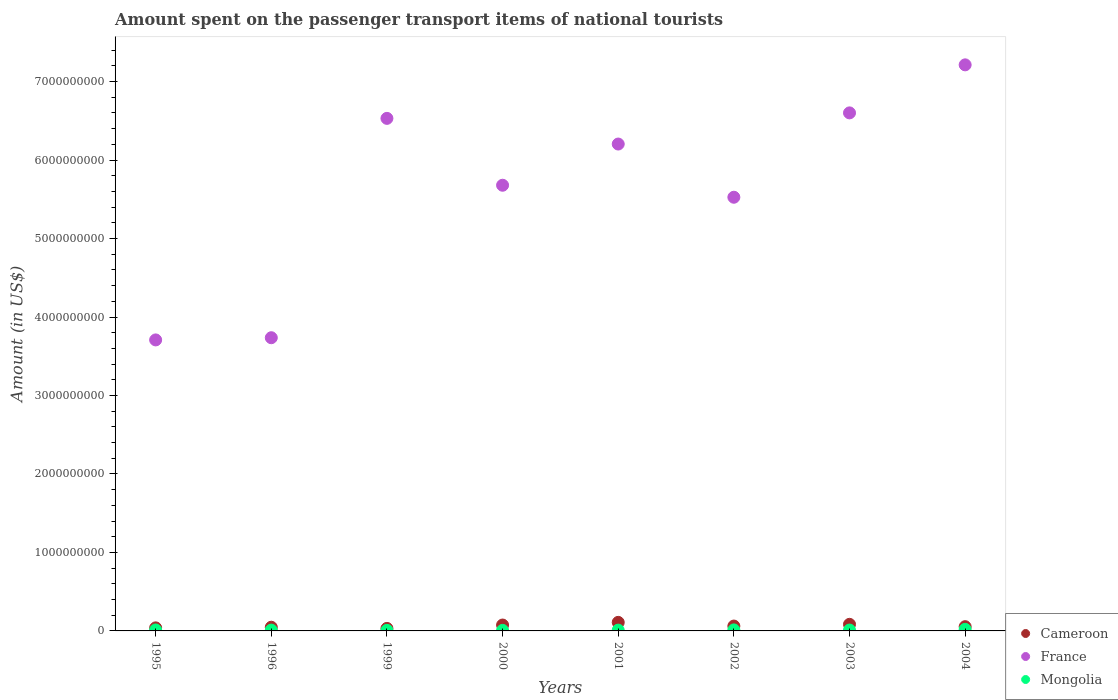How many different coloured dotlines are there?
Provide a succinct answer. 3. What is the amount spent on the passenger transport items of national tourists in Mongolia in 2001?
Your answer should be compact. 1.00e+07. Across all years, what is the maximum amount spent on the passenger transport items of national tourists in Cameroon?
Offer a terse response. 1.09e+08. Across all years, what is the minimum amount spent on the passenger transport items of national tourists in Mongolia?
Make the answer very short. 7.00e+06. In which year was the amount spent on the passenger transport items of national tourists in Cameroon maximum?
Provide a short and direct response. 2001. In which year was the amount spent on the passenger transport items of national tourists in Cameroon minimum?
Provide a short and direct response. 1999. What is the total amount spent on the passenger transport items of national tourists in Mongolia in the graph?
Provide a short and direct response. 9.00e+07. What is the difference between the amount spent on the passenger transport items of national tourists in France in 2000 and that in 2003?
Ensure brevity in your answer.  -9.22e+08. What is the difference between the amount spent on the passenger transport items of national tourists in Cameroon in 1999 and the amount spent on the passenger transport items of national tourists in Mongolia in 2000?
Keep it short and to the point. 2.50e+07. What is the average amount spent on the passenger transport items of national tourists in Cameroon per year?
Provide a short and direct response. 6.28e+07. In the year 2004, what is the difference between the amount spent on the passenger transport items of national tourists in France and amount spent on the passenger transport items of national tourists in Mongolia?
Make the answer very short. 7.19e+09. What is the ratio of the amount spent on the passenger transport items of national tourists in France in 1995 to that in 2001?
Your answer should be compact. 0.6. Is the amount spent on the passenger transport items of national tourists in France in 2000 less than that in 2001?
Your answer should be compact. Yes. Is the difference between the amount spent on the passenger transport items of national tourists in France in 1996 and 2004 greater than the difference between the amount spent on the passenger transport items of national tourists in Mongolia in 1996 and 2004?
Keep it short and to the point. No. What is the difference between the highest and the second highest amount spent on the passenger transport items of national tourists in Cameroon?
Offer a terse response. 2.50e+07. What is the difference between the highest and the lowest amount spent on the passenger transport items of national tourists in France?
Give a very brief answer. 3.50e+09. Is the sum of the amount spent on the passenger transport items of national tourists in Cameroon in 2002 and 2004 greater than the maximum amount spent on the passenger transport items of national tourists in France across all years?
Provide a succinct answer. No. Is it the case that in every year, the sum of the amount spent on the passenger transport items of national tourists in Mongolia and amount spent on the passenger transport items of national tourists in France  is greater than the amount spent on the passenger transport items of national tourists in Cameroon?
Give a very brief answer. Yes. Is the amount spent on the passenger transport items of national tourists in Cameroon strictly greater than the amount spent on the passenger transport items of national tourists in France over the years?
Your answer should be very brief. No. Is the amount spent on the passenger transport items of national tourists in Cameroon strictly less than the amount spent on the passenger transport items of national tourists in Mongolia over the years?
Give a very brief answer. No. Are the values on the major ticks of Y-axis written in scientific E-notation?
Your answer should be compact. No. Does the graph contain any zero values?
Give a very brief answer. No. Does the graph contain grids?
Give a very brief answer. No. Where does the legend appear in the graph?
Provide a succinct answer. Bottom right. What is the title of the graph?
Keep it short and to the point. Amount spent on the passenger transport items of national tourists. What is the Amount (in US$) in Cameroon in 1995?
Make the answer very short. 3.90e+07. What is the Amount (in US$) in France in 1995?
Make the answer very short. 3.71e+09. What is the Amount (in US$) of Mongolia in 1995?
Give a very brief answer. 1.20e+07. What is the Amount (in US$) in Cameroon in 1996?
Ensure brevity in your answer.  4.70e+07. What is the Amount (in US$) in France in 1996?
Make the answer very short. 3.74e+09. What is the Amount (in US$) of Mongolia in 1996?
Give a very brief answer. 1.00e+07. What is the Amount (in US$) in Cameroon in 1999?
Your response must be concise. 3.20e+07. What is the Amount (in US$) in France in 1999?
Make the answer very short. 6.53e+09. What is the Amount (in US$) of Cameroon in 2000?
Give a very brief answer. 7.50e+07. What is the Amount (in US$) in France in 2000?
Give a very brief answer. 5.68e+09. What is the Amount (in US$) of Cameroon in 2001?
Your response must be concise. 1.09e+08. What is the Amount (in US$) of France in 2001?
Ensure brevity in your answer.  6.20e+09. What is the Amount (in US$) in Cameroon in 2002?
Provide a short and direct response. 6.20e+07. What is the Amount (in US$) of France in 2002?
Offer a terse response. 5.53e+09. What is the Amount (in US$) of Mongolia in 2002?
Your answer should be very brief. 1.30e+07. What is the Amount (in US$) of Cameroon in 2003?
Keep it short and to the point. 8.40e+07. What is the Amount (in US$) in France in 2003?
Provide a short and direct response. 6.60e+09. What is the Amount (in US$) in Mongolia in 2003?
Ensure brevity in your answer.  1.10e+07. What is the Amount (in US$) of Cameroon in 2004?
Keep it short and to the point. 5.40e+07. What is the Amount (in US$) of France in 2004?
Offer a very short reply. 7.21e+09. Across all years, what is the maximum Amount (in US$) of Cameroon?
Provide a short and direct response. 1.09e+08. Across all years, what is the maximum Amount (in US$) of France?
Your answer should be compact. 7.21e+09. Across all years, what is the minimum Amount (in US$) in Cameroon?
Your answer should be compact. 3.20e+07. Across all years, what is the minimum Amount (in US$) of France?
Provide a short and direct response. 3.71e+09. Across all years, what is the minimum Amount (in US$) in Mongolia?
Provide a short and direct response. 7.00e+06. What is the total Amount (in US$) in Cameroon in the graph?
Provide a succinct answer. 5.02e+08. What is the total Amount (in US$) of France in the graph?
Make the answer very short. 4.52e+1. What is the total Amount (in US$) in Mongolia in the graph?
Provide a short and direct response. 9.00e+07. What is the difference between the Amount (in US$) in Cameroon in 1995 and that in 1996?
Give a very brief answer. -8.00e+06. What is the difference between the Amount (in US$) in France in 1995 and that in 1996?
Offer a terse response. -2.80e+07. What is the difference between the Amount (in US$) of France in 1995 and that in 1999?
Your answer should be compact. -2.82e+09. What is the difference between the Amount (in US$) of Cameroon in 1995 and that in 2000?
Provide a succinct answer. -3.60e+07. What is the difference between the Amount (in US$) in France in 1995 and that in 2000?
Your response must be concise. -1.97e+09. What is the difference between the Amount (in US$) of Cameroon in 1995 and that in 2001?
Ensure brevity in your answer.  -7.00e+07. What is the difference between the Amount (in US$) of France in 1995 and that in 2001?
Keep it short and to the point. -2.50e+09. What is the difference between the Amount (in US$) in Cameroon in 1995 and that in 2002?
Your response must be concise. -2.30e+07. What is the difference between the Amount (in US$) of France in 1995 and that in 2002?
Offer a terse response. -1.82e+09. What is the difference between the Amount (in US$) of Cameroon in 1995 and that in 2003?
Keep it short and to the point. -4.50e+07. What is the difference between the Amount (in US$) of France in 1995 and that in 2003?
Make the answer very short. -2.89e+09. What is the difference between the Amount (in US$) in Mongolia in 1995 and that in 2003?
Offer a very short reply. 1.00e+06. What is the difference between the Amount (in US$) of Cameroon in 1995 and that in 2004?
Keep it short and to the point. -1.50e+07. What is the difference between the Amount (in US$) of France in 1995 and that in 2004?
Make the answer very short. -3.50e+09. What is the difference between the Amount (in US$) in Mongolia in 1995 and that in 2004?
Offer a terse response. -8.00e+06. What is the difference between the Amount (in US$) of Cameroon in 1996 and that in 1999?
Provide a succinct answer. 1.50e+07. What is the difference between the Amount (in US$) in France in 1996 and that in 1999?
Offer a terse response. -2.80e+09. What is the difference between the Amount (in US$) of Mongolia in 1996 and that in 1999?
Give a very brief answer. 3.00e+06. What is the difference between the Amount (in US$) of Cameroon in 1996 and that in 2000?
Make the answer very short. -2.80e+07. What is the difference between the Amount (in US$) of France in 1996 and that in 2000?
Give a very brief answer. -1.94e+09. What is the difference between the Amount (in US$) in Cameroon in 1996 and that in 2001?
Provide a succinct answer. -6.20e+07. What is the difference between the Amount (in US$) in France in 1996 and that in 2001?
Ensure brevity in your answer.  -2.47e+09. What is the difference between the Amount (in US$) in Mongolia in 1996 and that in 2001?
Ensure brevity in your answer.  0. What is the difference between the Amount (in US$) of Cameroon in 1996 and that in 2002?
Ensure brevity in your answer.  -1.50e+07. What is the difference between the Amount (in US$) of France in 1996 and that in 2002?
Offer a terse response. -1.79e+09. What is the difference between the Amount (in US$) of Mongolia in 1996 and that in 2002?
Keep it short and to the point. -3.00e+06. What is the difference between the Amount (in US$) of Cameroon in 1996 and that in 2003?
Your response must be concise. -3.70e+07. What is the difference between the Amount (in US$) of France in 1996 and that in 2003?
Provide a short and direct response. -2.86e+09. What is the difference between the Amount (in US$) in Mongolia in 1996 and that in 2003?
Offer a terse response. -1.00e+06. What is the difference between the Amount (in US$) in Cameroon in 1996 and that in 2004?
Offer a terse response. -7.00e+06. What is the difference between the Amount (in US$) of France in 1996 and that in 2004?
Keep it short and to the point. -3.48e+09. What is the difference between the Amount (in US$) in Mongolia in 1996 and that in 2004?
Make the answer very short. -1.00e+07. What is the difference between the Amount (in US$) in Cameroon in 1999 and that in 2000?
Make the answer very short. -4.30e+07. What is the difference between the Amount (in US$) in France in 1999 and that in 2000?
Offer a very short reply. 8.52e+08. What is the difference between the Amount (in US$) in Cameroon in 1999 and that in 2001?
Keep it short and to the point. -7.70e+07. What is the difference between the Amount (in US$) in France in 1999 and that in 2001?
Offer a terse response. 3.27e+08. What is the difference between the Amount (in US$) in Mongolia in 1999 and that in 2001?
Offer a terse response. -3.00e+06. What is the difference between the Amount (in US$) of Cameroon in 1999 and that in 2002?
Your answer should be very brief. -3.00e+07. What is the difference between the Amount (in US$) in France in 1999 and that in 2002?
Provide a short and direct response. 1.00e+09. What is the difference between the Amount (in US$) of Mongolia in 1999 and that in 2002?
Your answer should be very brief. -6.00e+06. What is the difference between the Amount (in US$) of Cameroon in 1999 and that in 2003?
Your response must be concise. -5.20e+07. What is the difference between the Amount (in US$) of France in 1999 and that in 2003?
Provide a succinct answer. -7.00e+07. What is the difference between the Amount (in US$) of Mongolia in 1999 and that in 2003?
Your answer should be compact. -4.00e+06. What is the difference between the Amount (in US$) of Cameroon in 1999 and that in 2004?
Provide a succinct answer. -2.20e+07. What is the difference between the Amount (in US$) in France in 1999 and that in 2004?
Your answer should be very brief. -6.82e+08. What is the difference between the Amount (in US$) of Mongolia in 1999 and that in 2004?
Keep it short and to the point. -1.30e+07. What is the difference between the Amount (in US$) in Cameroon in 2000 and that in 2001?
Keep it short and to the point. -3.40e+07. What is the difference between the Amount (in US$) of France in 2000 and that in 2001?
Make the answer very short. -5.25e+08. What is the difference between the Amount (in US$) in Mongolia in 2000 and that in 2001?
Provide a succinct answer. -3.00e+06. What is the difference between the Amount (in US$) in Cameroon in 2000 and that in 2002?
Ensure brevity in your answer.  1.30e+07. What is the difference between the Amount (in US$) in France in 2000 and that in 2002?
Make the answer very short. 1.53e+08. What is the difference between the Amount (in US$) of Mongolia in 2000 and that in 2002?
Your response must be concise. -6.00e+06. What is the difference between the Amount (in US$) in Cameroon in 2000 and that in 2003?
Your response must be concise. -9.00e+06. What is the difference between the Amount (in US$) in France in 2000 and that in 2003?
Your answer should be very brief. -9.22e+08. What is the difference between the Amount (in US$) of Cameroon in 2000 and that in 2004?
Your answer should be very brief. 2.10e+07. What is the difference between the Amount (in US$) in France in 2000 and that in 2004?
Keep it short and to the point. -1.53e+09. What is the difference between the Amount (in US$) of Mongolia in 2000 and that in 2004?
Offer a terse response. -1.30e+07. What is the difference between the Amount (in US$) in Cameroon in 2001 and that in 2002?
Give a very brief answer. 4.70e+07. What is the difference between the Amount (in US$) in France in 2001 and that in 2002?
Give a very brief answer. 6.78e+08. What is the difference between the Amount (in US$) of Mongolia in 2001 and that in 2002?
Keep it short and to the point. -3.00e+06. What is the difference between the Amount (in US$) of Cameroon in 2001 and that in 2003?
Provide a succinct answer. 2.50e+07. What is the difference between the Amount (in US$) in France in 2001 and that in 2003?
Your answer should be very brief. -3.97e+08. What is the difference between the Amount (in US$) in Cameroon in 2001 and that in 2004?
Give a very brief answer. 5.50e+07. What is the difference between the Amount (in US$) of France in 2001 and that in 2004?
Make the answer very short. -1.01e+09. What is the difference between the Amount (in US$) in Mongolia in 2001 and that in 2004?
Provide a short and direct response. -1.00e+07. What is the difference between the Amount (in US$) in Cameroon in 2002 and that in 2003?
Offer a very short reply. -2.20e+07. What is the difference between the Amount (in US$) of France in 2002 and that in 2003?
Keep it short and to the point. -1.08e+09. What is the difference between the Amount (in US$) in Mongolia in 2002 and that in 2003?
Offer a very short reply. 2.00e+06. What is the difference between the Amount (in US$) of France in 2002 and that in 2004?
Your answer should be very brief. -1.69e+09. What is the difference between the Amount (in US$) in Mongolia in 2002 and that in 2004?
Keep it short and to the point. -7.00e+06. What is the difference between the Amount (in US$) in Cameroon in 2003 and that in 2004?
Provide a short and direct response. 3.00e+07. What is the difference between the Amount (in US$) of France in 2003 and that in 2004?
Give a very brief answer. -6.12e+08. What is the difference between the Amount (in US$) of Mongolia in 2003 and that in 2004?
Provide a succinct answer. -9.00e+06. What is the difference between the Amount (in US$) of Cameroon in 1995 and the Amount (in US$) of France in 1996?
Ensure brevity in your answer.  -3.70e+09. What is the difference between the Amount (in US$) of Cameroon in 1995 and the Amount (in US$) of Mongolia in 1996?
Your response must be concise. 2.90e+07. What is the difference between the Amount (in US$) in France in 1995 and the Amount (in US$) in Mongolia in 1996?
Your answer should be very brief. 3.70e+09. What is the difference between the Amount (in US$) of Cameroon in 1995 and the Amount (in US$) of France in 1999?
Offer a terse response. -6.49e+09. What is the difference between the Amount (in US$) of Cameroon in 1995 and the Amount (in US$) of Mongolia in 1999?
Offer a terse response. 3.20e+07. What is the difference between the Amount (in US$) of France in 1995 and the Amount (in US$) of Mongolia in 1999?
Offer a terse response. 3.70e+09. What is the difference between the Amount (in US$) in Cameroon in 1995 and the Amount (in US$) in France in 2000?
Keep it short and to the point. -5.64e+09. What is the difference between the Amount (in US$) in Cameroon in 1995 and the Amount (in US$) in Mongolia in 2000?
Ensure brevity in your answer.  3.20e+07. What is the difference between the Amount (in US$) of France in 1995 and the Amount (in US$) of Mongolia in 2000?
Your answer should be compact. 3.70e+09. What is the difference between the Amount (in US$) in Cameroon in 1995 and the Amount (in US$) in France in 2001?
Your answer should be compact. -6.16e+09. What is the difference between the Amount (in US$) of Cameroon in 1995 and the Amount (in US$) of Mongolia in 2001?
Ensure brevity in your answer.  2.90e+07. What is the difference between the Amount (in US$) in France in 1995 and the Amount (in US$) in Mongolia in 2001?
Give a very brief answer. 3.70e+09. What is the difference between the Amount (in US$) of Cameroon in 1995 and the Amount (in US$) of France in 2002?
Your response must be concise. -5.49e+09. What is the difference between the Amount (in US$) in Cameroon in 1995 and the Amount (in US$) in Mongolia in 2002?
Your answer should be very brief. 2.60e+07. What is the difference between the Amount (in US$) in France in 1995 and the Amount (in US$) in Mongolia in 2002?
Make the answer very short. 3.70e+09. What is the difference between the Amount (in US$) of Cameroon in 1995 and the Amount (in US$) of France in 2003?
Your answer should be very brief. -6.56e+09. What is the difference between the Amount (in US$) of Cameroon in 1995 and the Amount (in US$) of Mongolia in 2003?
Make the answer very short. 2.80e+07. What is the difference between the Amount (in US$) of France in 1995 and the Amount (in US$) of Mongolia in 2003?
Provide a short and direct response. 3.70e+09. What is the difference between the Amount (in US$) of Cameroon in 1995 and the Amount (in US$) of France in 2004?
Ensure brevity in your answer.  -7.17e+09. What is the difference between the Amount (in US$) in Cameroon in 1995 and the Amount (in US$) in Mongolia in 2004?
Give a very brief answer. 1.90e+07. What is the difference between the Amount (in US$) in France in 1995 and the Amount (in US$) in Mongolia in 2004?
Your response must be concise. 3.69e+09. What is the difference between the Amount (in US$) of Cameroon in 1996 and the Amount (in US$) of France in 1999?
Provide a short and direct response. -6.48e+09. What is the difference between the Amount (in US$) in Cameroon in 1996 and the Amount (in US$) in Mongolia in 1999?
Offer a terse response. 4.00e+07. What is the difference between the Amount (in US$) in France in 1996 and the Amount (in US$) in Mongolia in 1999?
Make the answer very short. 3.73e+09. What is the difference between the Amount (in US$) in Cameroon in 1996 and the Amount (in US$) in France in 2000?
Provide a short and direct response. -5.63e+09. What is the difference between the Amount (in US$) of Cameroon in 1996 and the Amount (in US$) of Mongolia in 2000?
Offer a very short reply. 4.00e+07. What is the difference between the Amount (in US$) in France in 1996 and the Amount (in US$) in Mongolia in 2000?
Your response must be concise. 3.73e+09. What is the difference between the Amount (in US$) of Cameroon in 1996 and the Amount (in US$) of France in 2001?
Provide a succinct answer. -6.16e+09. What is the difference between the Amount (in US$) of Cameroon in 1996 and the Amount (in US$) of Mongolia in 2001?
Make the answer very short. 3.70e+07. What is the difference between the Amount (in US$) in France in 1996 and the Amount (in US$) in Mongolia in 2001?
Make the answer very short. 3.73e+09. What is the difference between the Amount (in US$) of Cameroon in 1996 and the Amount (in US$) of France in 2002?
Ensure brevity in your answer.  -5.48e+09. What is the difference between the Amount (in US$) in Cameroon in 1996 and the Amount (in US$) in Mongolia in 2002?
Make the answer very short. 3.40e+07. What is the difference between the Amount (in US$) of France in 1996 and the Amount (in US$) of Mongolia in 2002?
Make the answer very short. 3.72e+09. What is the difference between the Amount (in US$) of Cameroon in 1996 and the Amount (in US$) of France in 2003?
Keep it short and to the point. -6.55e+09. What is the difference between the Amount (in US$) of Cameroon in 1996 and the Amount (in US$) of Mongolia in 2003?
Offer a terse response. 3.60e+07. What is the difference between the Amount (in US$) in France in 1996 and the Amount (in US$) in Mongolia in 2003?
Offer a very short reply. 3.72e+09. What is the difference between the Amount (in US$) of Cameroon in 1996 and the Amount (in US$) of France in 2004?
Your answer should be very brief. -7.17e+09. What is the difference between the Amount (in US$) of Cameroon in 1996 and the Amount (in US$) of Mongolia in 2004?
Offer a very short reply. 2.70e+07. What is the difference between the Amount (in US$) of France in 1996 and the Amount (in US$) of Mongolia in 2004?
Offer a very short reply. 3.72e+09. What is the difference between the Amount (in US$) of Cameroon in 1999 and the Amount (in US$) of France in 2000?
Offer a terse response. -5.65e+09. What is the difference between the Amount (in US$) in Cameroon in 1999 and the Amount (in US$) in Mongolia in 2000?
Provide a short and direct response. 2.50e+07. What is the difference between the Amount (in US$) of France in 1999 and the Amount (in US$) of Mongolia in 2000?
Your answer should be very brief. 6.52e+09. What is the difference between the Amount (in US$) in Cameroon in 1999 and the Amount (in US$) in France in 2001?
Make the answer very short. -6.17e+09. What is the difference between the Amount (in US$) in Cameroon in 1999 and the Amount (in US$) in Mongolia in 2001?
Offer a very short reply. 2.20e+07. What is the difference between the Amount (in US$) in France in 1999 and the Amount (in US$) in Mongolia in 2001?
Your answer should be compact. 6.52e+09. What is the difference between the Amount (in US$) of Cameroon in 1999 and the Amount (in US$) of France in 2002?
Your response must be concise. -5.49e+09. What is the difference between the Amount (in US$) in Cameroon in 1999 and the Amount (in US$) in Mongolia in 2002?
Your answer should be compact. 1.90e+07. What is the difference between the Amount (in US$) in France in 1999 and the Amount (in US$) in Mongolia in 2002?
Make the answer very short. 6.52e+09. What is the difference between the Amount (in US$) of Cameroon in 1999 and the Amount (in US$) of France in 2003?
Make the answer very short. -6.57e+09. What is the difference between the Amount (in US$) in Cameroon in 1999 and the Amount (in US$) in Mongolia in 2003?
Offer a very short reply. 2.10e+07. What is the difference between the Amount (in US$) in France in 1999 and the Amount (in US$) in Mongolia in 2003?
Provide a succinct answer. 6.52e+09. What is the difference between the Amount (in US$) in Cameroon in 1999 and the Amount (in US$) in France in 2004?
Make the answer very short. -7.18e+09. What is the difference between the Amount (in US$) in Cameroon in 1999 and the Amount (in US$) in Mongolia in 2004?
Your answer should be compact. 1.20e+07. What is the difference between the Amount (in US$) of France in 1999 and the Amount (in US$) of Mongolia in 2004?
Offer a terse response. 6.51e+09. What is the difference between the Amount (in US$) in Cameroon in 2000 and the Amount (in US$) in France in 2001?
Your answer should be compact. -6.13e+09. What is the difference between the Amount (in US$) of Cameroon in 2000 and the Amount (in US$) of Mongolia in 2001?
Ensure brevity in your answer.  6.50e+07. What is the difference between the Amount (in US$) in France in 2000 and the Amount (in US$) in Mongolia in 2001?
Make the answer very short. 5.67e+09. What is the difference between the Amount (in US$) in Cameroon in 2000 and the Amount (in US$) in France in 2002?
Offer a very short reply. -5.45e+09. What is the difference between the Amount (in US$) in Cameroon in 2000 and the Amount (in US$) in Mongolia in 2002?
Make the answer very short. 6.20e+07. What is the difference between the Amount (in US$) in France in 2000 and the Amount (in US$) in Mongolia in 2002?
Give a very brief answer. 5.67e+09. What is the difference between the Amount (in US$) of Cameroon in 2000 and the Amount (in US$) of France in 2003?
Make the answer very short. -6.53e+09. What is the difference between the Amount (in US$) in Cameroon in 2000 and the Amount (in US$) in Mongolia in 2003?
Your answer should be very brief. 6.40e+07. What is the difference between the Amount (in US$) of France in 2000 and the Amount (in US$) of Mongolia in 2003?
Give a very brief answer. 5.67e+09. What is the difference between the Amount (in US$) of Cameroon in 2000 and the Amount (in US$) of France in 2004?
Offer a very short reply. -7.14e+09. What is the difference between the Amount (in US$) of Cameroon in 2000 and the Amount (in US$) of Mongolia in 2004?
Give a very brief answer. 5.50e+07. What is the difference between the Amount (in US$) of France in 2000 and the Amount (in US$) of Mongolia in 2004?
Your answer should be very brief. 5.66e+09. What is the difference between the Amount (in US$) of Cameroon in 2001 and the Amount (in US$) of France in 2002?
Your answer should be compact. -5.42e+09. What is the difference between the Amount (in US$) of Cameroon in 2001 and the Amount (in US$) of Mongolia in 2002?
Keep it short and to the point. 9.60e+07. What is the difference between the Amount (in US$) in France in 2001 and the Amount (in US$) in Mongolia in 2002?
Keep it short and to the point. 6.19e+09. What is the difference between the Amount (in US$) in Cameroon in 2001 and the Amount (in US$) in France in 2003?
Your response must be concise. -6.49e+09. What is the difference between the Amount (in US$) of Cameroon in 2001 and the Amount (in US$) of Mongolia in 2003?
Provide a short and direct response. 9.80e+07. What is the difference between the Amount (in US$) in France in 2001 and the Amount (in US$) in Mongolia in 2003?
Your answer should be compact. 6.19e+09. What is the difference between the Amount (in US$) in Cameroon in 2001 and the Amount (in US$) in France in 2004?
Your response must be concise. -7.10e+09. What is the difference between the Amount (in US$) of Cameroon in 2001 and the Amount (in US$) of Mongolia in 2004?
Give a very brief answer. 8.90e+07. What is the difference between the Amount (in US$) of France in 2001 and the Amount (in US$) of Mongolia in 2004?
Ensure brevity in your answer.  6.18e+09. What is the difference between the Amount (in US$) of Cameroon in 2002 and the Amount (in US$) of France in 2003?
Offer a very short reply. -6.54e+09. What is the difference between the Amount (in US$) in Cameroon in 2002 and the Amount (in US$) in Mongolia in 2003?
Offer a very short reply. 5.10e+07. What is the difference between the Amount (in US$) of France in 2002 and the Amount (in US$) of Mongolia in 2003?
Your response must be concise. 5.52e+09. What is the difference between the Amount (in US$) of Cameroon in 2002 and the Amount (in US$) of France in 2004?
Keep it short and to the point. -7.15e+09. What is the difference between the Amount (in US$) of Cameroon in 2002 and the Amount (in US$) of Mongolia in 2004?
Make the answer very short. 4.20e+07. What is the difference between the Amount (in US$) in France in 2002 and the Amount (in US$) in Mongolia in 2004?
Provide a short and direct response. 5.51e+09. What is the difference between the Amount (in US$) in Cameroon in 2003 and the Amount (in US$) in France in 2004?
Your answer should be compact. -7.13e+09. What is the difference between the Amount (in US$) in Cameroon in 2003 and the Amount (in US$) in Mongolia in 2004?
Your answer should be compact. 6.40e+07. What is the difference between the Amount (in US$) in France in 2003 and the Amount (in US$) in Mongolia in 2004?
Offer a very short reply. 6.58e+09. What is the average Amount (in US$) in Cameroon per year?
Give a very brief answer. 6.28e+07. What is the average Amount (in US$) of France per year?
Provide a succinct answer. 5.65e+09. What is the average Amount (in US$) of Mongolia per year?
Make the answer very short. 1.12e+07. In the year 1995, what is the difference between the Amount (in US$) in Cameroon and Amount (in US$) in France?
Ensure brevity in your answer.  -3.67e+09. In the year 1995, what is the difference between the Amount (in US$) in Cameroon and Amount (in US$) in Mongolia?
Your answer should be very brief. 2.70e+07. In the year 1995, what is the difference between the Amount (in US$) in France and Amount (in US$) in Mongolia?
Offer a terse response. 3.70e+09. In the year 1996, what is the difference between the Amount (in US$) in Cameroon and Amount (in US$) in France?
Keep it short and to the point. -3.69e+09. In the year 1996, what is the difference between the Amount (in US$) of Cameroon and Amount (in US$) of Mongolia?
Give a very brief answer. 3.70e+07. In the year 1996, what is the difference between the Amount (in US$) in France and Amount (in US$) in Mongolia?
Make the answer very short. 3.73e+09. In the year 1999, what is the difference between the Amount (in US$) in Cameroon and Amount (in US$) in France?
Give a very brief answer. -6.50e+09. In the year 1999, what is the difference between the Amount (in US$) of Cameroon and Amount (in US$) of Mongolia?
Keep it short and to the point. 2.50e+07. In the year 1999, what is the difference between the Amount (in US$) in France and Amount (in US$) in Mongolia?
Keep it short and to the point. 6.52e+09. In the year 2000, what is the difference between the Amount (in US$) of Cameroon and Amount (in US$) of France?
Make the answer very short. -5.60e+09. In the year 2000, what is the difference between the Amount (in US$) of Cameroon and Amount (in US$) of Mongolia?
Keep it short and to the point. 6.80e+07. In the year 2000, what is the difference between the Amount (in US$) in France and Amount (in US$) in Mongolia?
Keep it short and to the point. 5.67e+09. In the year 2001, what is the difference between the Amount (in US$) of Cameroon and Amount (in US$) of France?
Provide a short and direct response. -6.10e+09. In the year 2001, what is the difference between the Amount (in US$) in Cameroon and Amount (in US$) in Mongolia?
Give a very brief answer. 9.90e+07. In the year 2001, what is the difference between the Amount (in US$) in France and Amount (in US$) in Mongolia?
Provide a short and direct response. 6.19e+09. In the year 2002, what is the difference between the Amount (in US$) in Cameroon and Amount (in US$) in France?
Ensure brevity in your answer.  -5.46e+09. In the year 2002, what is the difference between the Amount (in US$) of Cameroon and Amount (in US$) of Mongolia?
Make the answer very short. 4.90e+07. In the year 2002, what is the difference between the Amount (in US$) of France and Amount (in US$) of Mongolia?
Offer a very short reply. 5.51e+09. In the year 2003, what is the difference between the Amount (in US$) in Cameroon and Amount (in US$) in France?
Provide a succinct answer. -6.52e+09. In the year 2003, what is the difference between the Amount (in US$) in Cameroon and Amount (in US$) in Mongolia?
Offer a terse response. 7.30e+07. In the year 2003, what is the difference between the Amount (in US$) of France and Amount (in US$) of Mongolia?
Provide a short and direct response. 6.59e+09. In the year 2004, what is the difference between the Amount (in US$) in Cameroon and Amount (in US$) in France?
Provide a succinct answer. -7.16e+09. In the year 2004, what is the difference between the Amount (in US$) of Cameroon and Amount (in US$) of Mongolia?
Your answer should be compact. 3.40e+07. In the year 2004, what is the difference between the Amount (in US$) of France and Amount (in US$) of Mongolia?
Your response must be concise. 7.19e+09. What is the ratio of the Amount (in US$) of Cameroon in 1995 to that in 1996?
Offer a very short reply. 0.83. What is the ratio of the Amount (in US$) in France in 1995 to that in 1996?
Give a very brief answer. 0.99. What is the ratio of the Amount (in US$) in Cameroon in 1995 to that in 1999?
Keep it short and to the point. 1.22. What is the ratio of the Amount (in US$) of France in 1995 to that in 1999?
Offer a very short reply. 0.57. What is the ratio of the Amount (in US$) of Mongolia in 1995 to that in 1999?
Make the answer very short. 1.71. What is the ratio of the Amount (in US$) in Cameroon in 1995 to that in 2000?
Keep it short and to the point. 0.52. What is the ratio of the Amount (in US$) in France in 1995 to that in 2000?
Make the answer very short. 0.65. What is the ratio of the Amount (in US$) in Mongolia in 1995 to that in 2000?
Offer a terse response. 1.71. What is the ratio of the Amount (in US$) of Cameroon in 1995 to that in 2001?
Offer a very short reply. 0.36. What is the ratio of the Amount (in US$) in France in 1995 to that in 2001?
Your answer should be very brief. 0.6. What is the ratio of the Amount (in US$) in Cameroon in 1995 to that in 2002?
Give a very brief answer. 0.63. What is the ratio of the Amount (in US$) of France in 1995 to that in 2002?
Ensure brevity in your answer.  0.67. What is the ratio of the Amount (in US$) in Mongolia in 1995 to that in 2002?
Provide a succinct answer. 0.92. What is the ratio of the Amount (in US$) in Cameroon in 1995 to that in 2003?
Your answer should be very brief. 0.46. What is the ratio of the Amount (in US$) in France in 1995 to that in 2003?
Your answer should be compact. 0.56. What is the ratio of the Amount (in US$) in Mongolia in 1995 to that in 2003?
Keep it short and to the point. 1.09. What is the ratio of the Amount (in US$) in Cameroon in 1995 to that in 2004?
Your answer should be compact. 0.72. What is the ratio of the Amount (in US$) in France in 1995 to that in 2004?
Provide a succinct answer. 0.51. What is the ratio of the Amount (in US$) of Mongolia in 1995 to that in 2004?
Ensure brevity in your answer.  0.6. What is the ratio of the Amount (in US$) in Cameroon in 1996 to that in 1999?
Ensure brevity in your answer.  1.47. What is the ratio of the Amount (in US$) of France in 1996 to that in 1999?
Keep it short and to the point. 0.57. What is the ratio of the Amount (in US$) of Mongolia in 1996 to that in 1999?
Offer a terse response. 1.43. What is the ratio of the Amount (in US$) of Cameroon in 1996 to that in 2000?
Your response must be concise. 0.63. What is the ratio of the Amount (in US$) of France in 1996 to that in 2000?
Your response must be concise. 0.66. What is the ratio of the Amount (in US$) of Mongolia in 1996 to that in 2000?
Provide a succinct answer. 1.43. What is the ratio of the Amount (in US$) of Cameroon in 1996 to that in 2001?
Your answer should be very brief. 0.43. What is the ratio of the Amount (in US$) in France in 1996 to that in 2001?
Make the answer very short. 0.6. What is the ratio of the Amount (in US$) in Cameroon in 1996 to that in 2002?
Make the answer very short. 0.76. What is the ratio of the Amount (in US$) in France in 1996 to that in 2002?
Your response must be concise. 0.68. What is the ratio of the Amount (in US$) of Mongolia in 1996 to that in 2002?
Your answer should be very brief. 0.77. What is the ratio of the Amount (in US$) in Cameroon in 1996 to that in 2003?
Provide a short and direct response. 0.56. What is the ratio of the Amount (in US$) in France in 1996 to that in 2003?
Your answer should be compact. 0.57. What is the ratio of the Amount (in US$) of Mongolia in 1996 to that in 2003?
Keep it short and to the point. 0.91. What is the ratio of the Amount (in US$) in Cameroon in 1996 to that in 2004?
Your response must be concise. 0.87. What is the ratio of the Amount (in US$) in France in 1996 to that in 2004?
Make the answer very short. 0.52. What is the ratio of the Amount (in US$) of Cameroon in 1999 to that in 2000?
Your answer should be compact. 0.43. What is the ratio of the Amount (in US$) in France in 1999 to that in 2000?
Keep it short and to the point. 1.15. What is the ratio of the Amount (in US$) in Cameroon in 1999 to that in 2001?
Give a very brief answer. 0.29. What is the ratio of the Amount (in US$) in France in 1999 to that in 2001?
Give a very brief answer. 1.05. What is the ratio of the Amount (in US$) of Mongolia in 1999 to that in 2001?
Offer a very short reply. 0.7. What is the ratio of the Amount (in US$) of Cameroon in 1999 to that in 2002?
Give a very brief answer. 0.52. What is the ratio of the Amount (in US$) of France in 1999 to that in 2002?
Keep it short and to the point. 1.18. What is the ratio of the Amount (in US$) in Mongolia in 1999 to that in 2002?
Your answer should be very brief. 0.54. What is the ratio of the Amount (in US$) of Cameroon in 1999 to that in 2003?
Ensure brevity in your answer.  0.38. What is the ratio of the Amount (in US$) in France in 1999 to that in 2003?
Keep it short and to the point. 0.99. What is the ratio of the Amount (in US$) of Mongolia in 1999 to that in 2003?
Give a very brief answer. 0.64. What is the ratio of the Amount (in US$) of Cameroon in 1999 to that in 2004?
Provide a succinct answer. 0.59. What is the ratio of the Amount (in US$) in France in 1999 to that in 2004?
Your answer should be very brief. 0.91. What is the ratio of the Amount (in US$) in Cameroon in 2000 to that in 2001?
Provide a succinct answer. 0.69. What is the ratio of the Amount (in US$) of France in 2000 to that in 2001?
Keep it short and to the point. 0.92. What is the ratio of the Amount (in US$) in Cameroon in 2000 to that in 2002?
Your response must be concise. 1.21. What is the ratio of the Amount (in US$) in France in 2000 to that in 2002?
Make the answer very short. 1.03. What is the ratio of the Amount (in US$) of Mongolia in 2000 to that in 2002?
Make the answer very short. 0.54. What is the ratio of the Amount (in US$) in Cameroon in 2000 to that in 2003?
Provide a succinct answer. 0.89. What is the ratio of the Amount (in US$) of France in 2000 to that in 2003?
Keep it short and to the point. 0.86. What is the ratio of the Amount (in US$) of Mongolia in 2000 to that in 2003?
Your answer should be very brief. 0.64. What is the ratio of the Amount (in US$) of Cameroon in 2000 to that in 2004?
Make the answer very short. 1.39. What is the ratio of the Amount (in US$) of France in 2000 to that in 2004?
Ensure brevity in your answer.  0.79. What is the ratio of the Amount (in US$) in Mongolia in 2000 to that in 2004?
Your answer should be very brief. 0.35. What is the ratio of the Amount (in US$) of Cameroon in 2001 to that in 2002?
Provide a succinct answer. 1.76. What is the ratio of the Amount (in US$) in France in 2001 to that in 2002?
Your answer should be compact. 1.12. What is the ratio of the Amount (in US$) of Mongolia in 2001 to that in 2002?
Keep it short and to the point. 0.77. What is the ratio of the Amount (in US$) of Cameroon in 2001 to that in 2003?
Ensure brevity in your answer.  1.3. What is the ratio of the Amount (in US$) in France in 2001 to that in 2003?
Make the answer very short. 0.94. What is the ratio of the Amount (in US$) of Cameroon in 2001 to that in 2004?
Provide a succinct answer. 2.02. What is the ratio of the Amount (in US$) of France in 2001 to that in 2004?
Your response must be concise. 0.86. What is the ratio of the Amount (in US$) in Cameroon in 2002 to that in 2003?
Offer a very short reply. 0.74. What is the ratio of the Amount (in US$) of France in 2002 to that in 2003?
Provide a short and direct response. 0.84. What is the ratio of the Amount (in US$) in Mongolia in 2002 to that in 2003?
Your response must be concise. 1.18. What is the ratio of the Amount (in US$) of Cameroon in 2002 to that in 2004?
Your response must be concise. 1.15. What is the ratio of the Amount (in US$) of France in 2002 to that in 2004?
Provide a succinct answer. 0.77. What is the ratio of the Amount (in US$) of Mongolia in 2002 to that in 2004?
Your response must be concise. 0.65. What is the ratio of the Amount (in US$) in Cameroon in 2003 to that in 2004?
Give a very brief answer. 1.56. What is the ratio of the Amount (in US$) in France in 2003 to that in 2004?
Keep it short and to the point. 0.92. What is the ratio of the Amount (in US$) in Mongolia in 2003 to that in 2004?
Offer a terse response. 0.55. What is the difference between the highest and the second highest Amount (in US$) of Cameroon?
Offer a terse response. 2.50e+07. What is the difference between the highest and the second highest Amount (in US$) of France?
Your response must be concise. 6.12e+08. What is the difference between the highest and the second highest Amount (in US$) in Mongolia?
Provide a short and direct response. 7.00e+06. What is the difference between the highest and the lowest Amount (in US$) of Cameroon?
Make the answer very short. 7.70e+07. What is the difference between the highest and the lowest Amount (in US$) of France?
Ensure brevity in your answer.  3.50e+09. What is the difference between the highest and the lowest Amount (in US$) in Mongolia?
Your answer should be compact. 1.30e+07. 